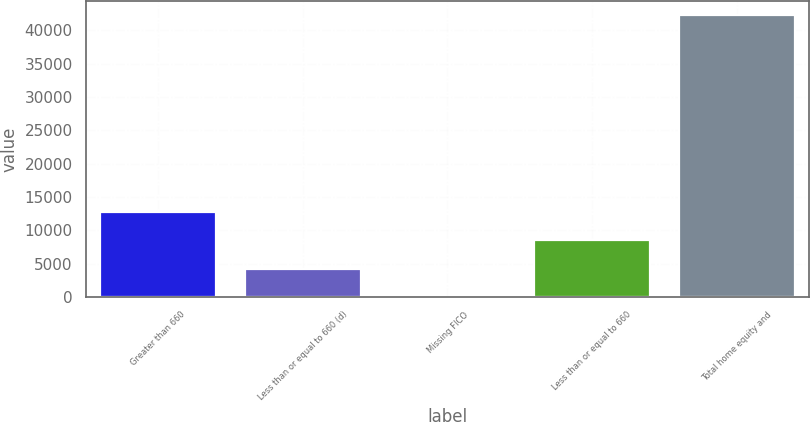Convert chart. <chart><loc_0><loc_0><loc_500><loc_500><bar_chart><fcel>Greater than 660<fcel>Less than or equal to 660 (d)<fcel>Missing FICO<fcel>Less than or equal to 660<fcel>Total home equity and<nl><fcel>12690.2<fcel>4239.4<fcel>14<fcel>8464.8<fcel>42268<nl></chart> 